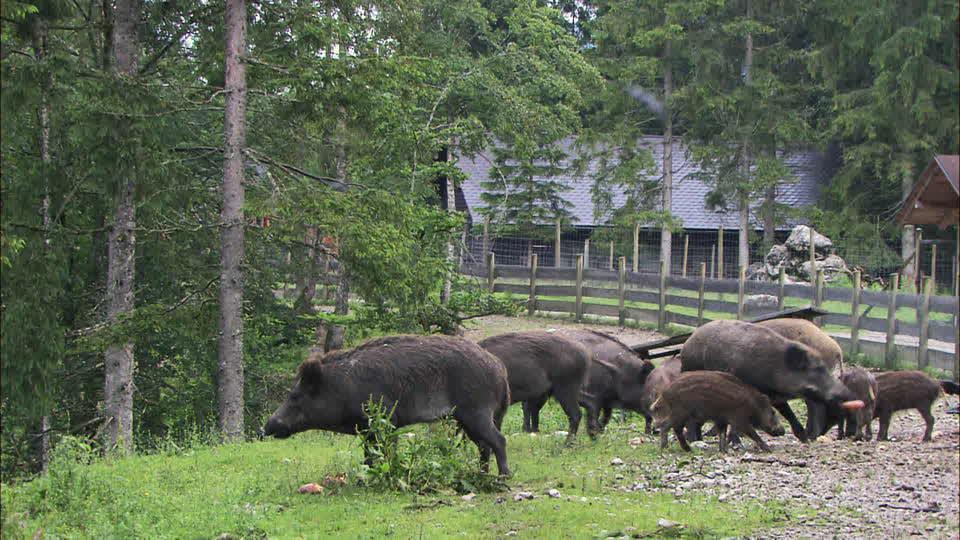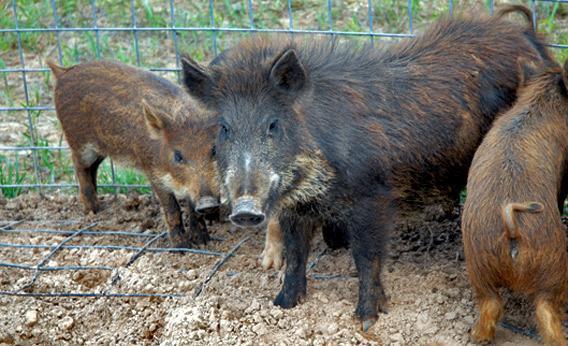The first image is the image on the left, the second image is the image on the right. Assess this claim about the two images: "Trees with green branches are behind a group of hogs in one image.". Correct or not? Answer yes or no. Yes. The first image is the image on the left, the second image is the image on the right. Analyze the images presented: Is the assertion "There are exactly three animals in the image on the right." valid? Answer yes or no. Yes. 